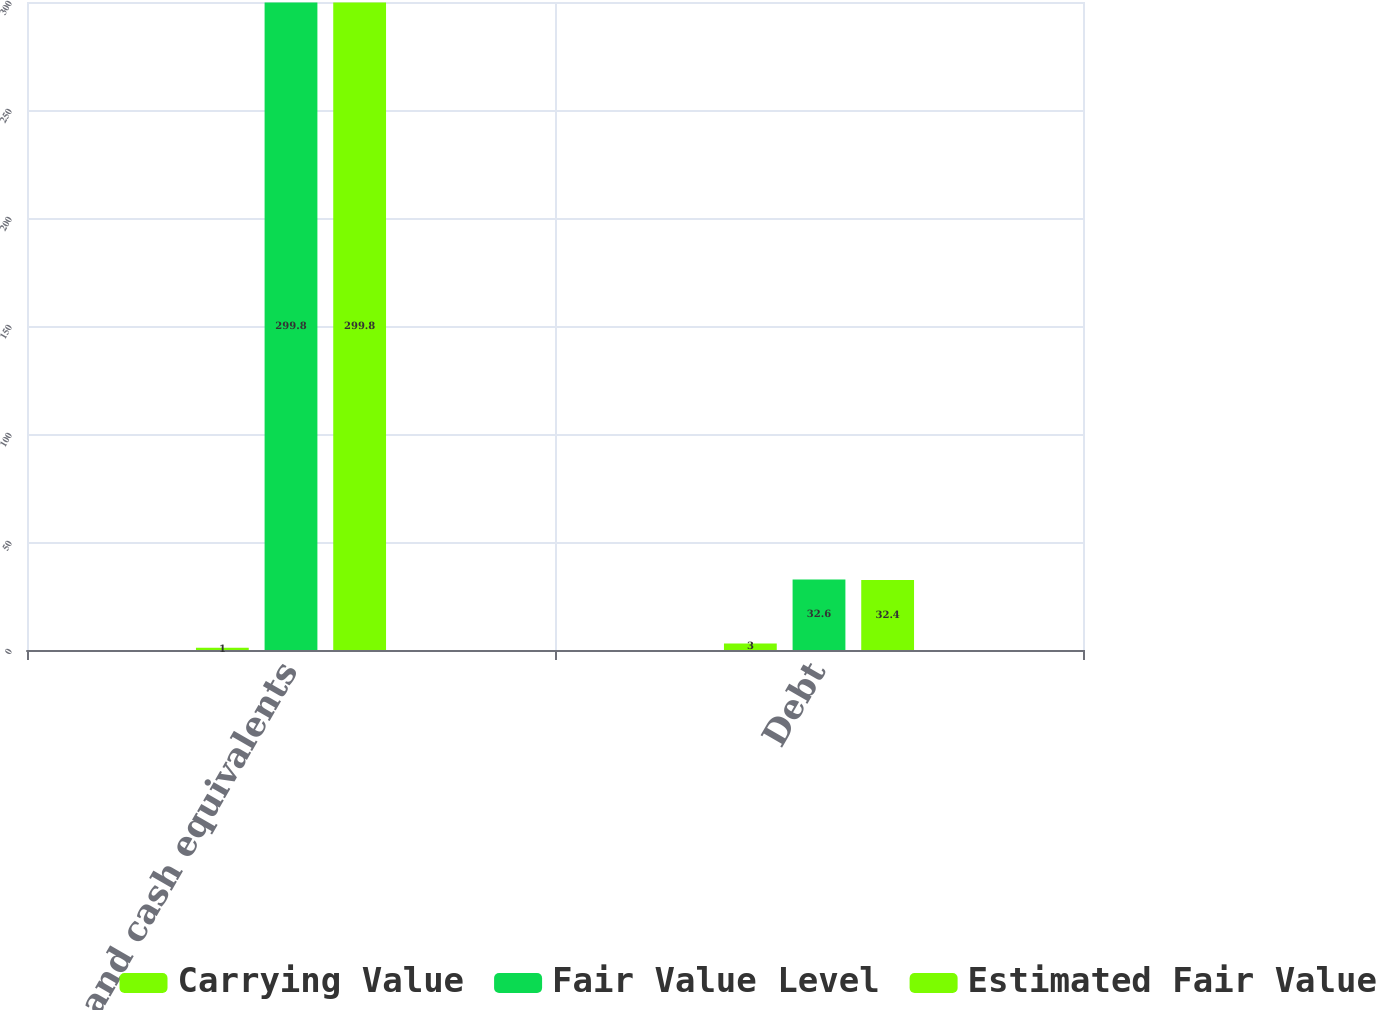Convert chart to OTSL. <chart><loc_0><loc_0><loc_500><loc_500><stacked_bar_chart><ecel><fcel>Cash and cash equivalents<fcel>Debt<nl><fcel>Carrying Value<fcel>1<fcel>3<nl><fcel>Fair Value Level<fcel>299.8<fcel>32.6<nl><fcel>Estimated Fair Value<fcel>299.8<fcel>32.4<nl></chart> 